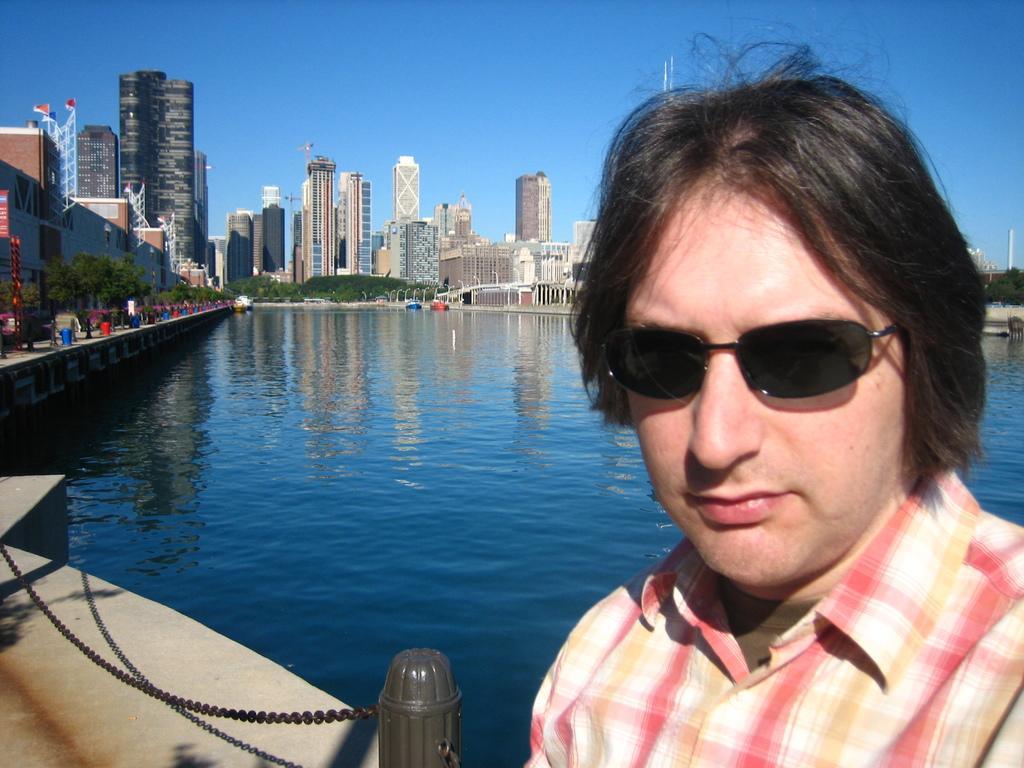Can you describe this image briefly? In this image we can see a man is standing, he is wearing the glasses, there is a fencing, at the back there are buildings, there are trees, there is the water, there are group of persons standing, there is a tower, there is a sky. 